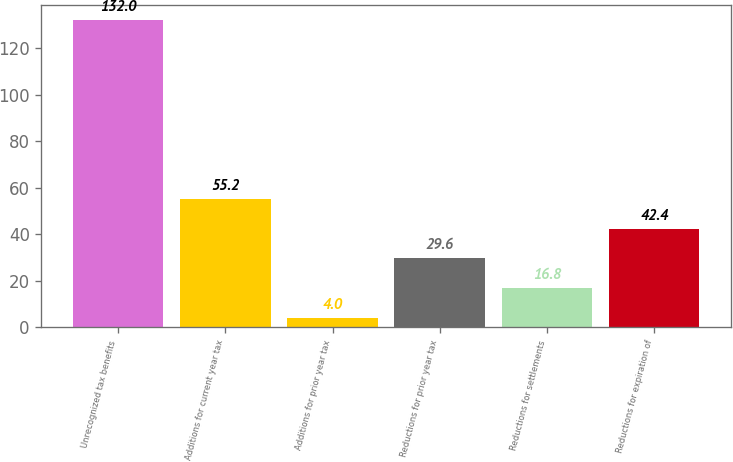Convert chart to OTSL. <chart><loc_0><loc_0><loc_500><loc_500><bar_chart><fcel>Unrecognized tax benefits<fcel>Additions for current year tax<fcel>Additions for prior year tax<fcel>Reductions for prior year tax<fcel>Reductions for settlements<fcel>Reductions for expiration of<nl><fcel>132<fcel>55.2<fcel>4<fcel>29.6<fcel>16.8<fcel>42.4<nl></chart> 